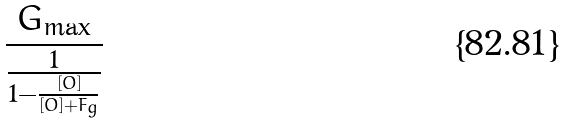<formula> <loc_0><loc_0><loc_500><loc_500>\frac { G _ { \max } } { \frac { 1 } { 1 - \frac { [ O ] } { [ O ] + F _ { g } } } }</formula> 